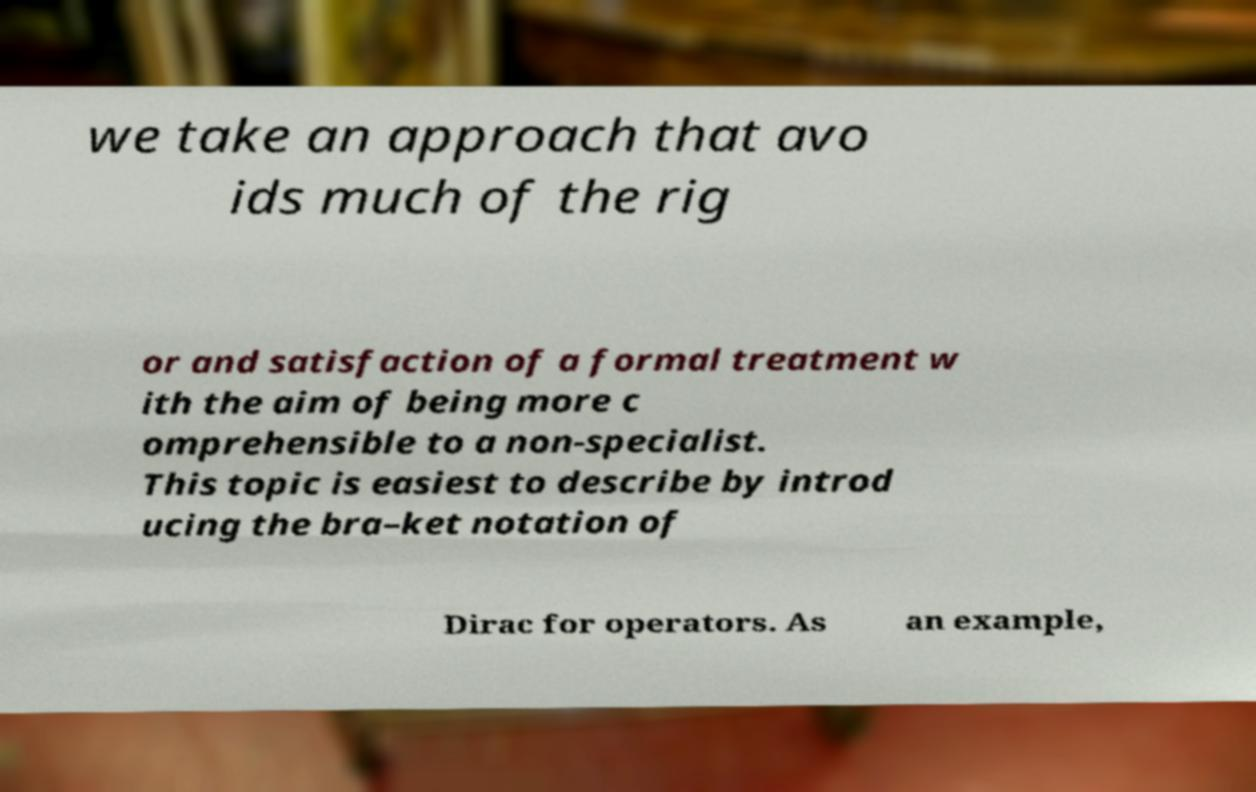What messages or text are displayed in this image? I need them in a readable, typed format. we take an approach that avo ids much of the rig or and satisfaction of a formal treatment w ith the aim of being more c omprehensible to a non-specialist. This topic is easiest to describe by introd ucing the bra–ket notation of Dirac for operators. As an example, 